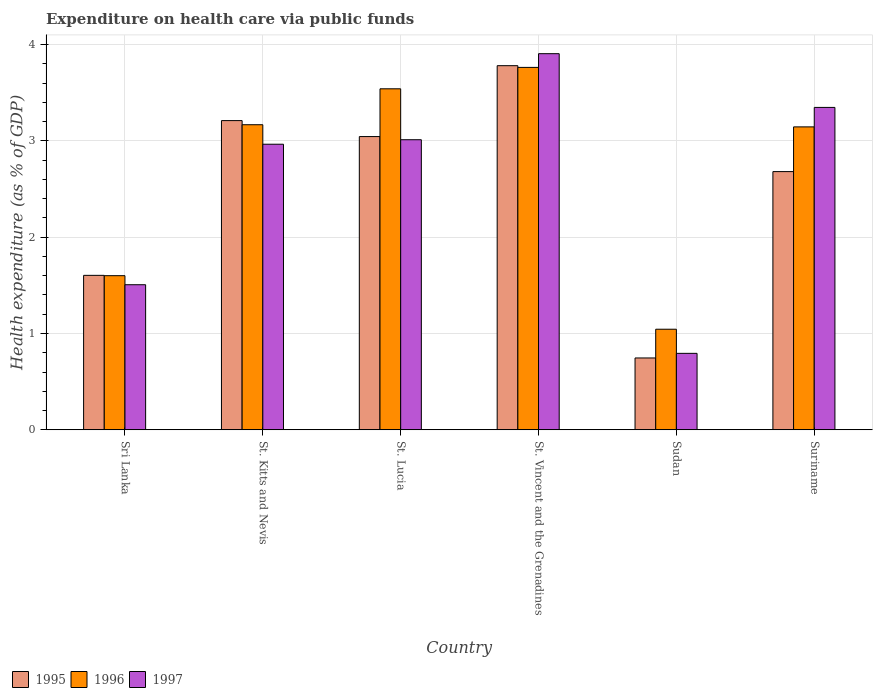How many groups of bars are there?
Your response must be concise. 6. How many bars are there on the 4th tick from the right?
Keep it short and to the point. 3. What is the label of the 2nd group of bars from the left?
Offer a terse response. St. Kitts and Nevis. What is the expenditure made on health care in 1997 in Sri Lanka?
Offer a terse response. 1.51. Across all countries, what is the maximum expenditure made on health care in 1995?
Provide a short and direct response. 3.78. Across all countries, what is the minimum expenditure made on health care in 1996?
Provide a short and direct response. 1.04. In which country was the expenditure made on health care in 1996 maximum?
Provide a succinct answer. St. Vincent and the Grenadines. In which country was the expenditure made on health care in 1997 minimum?
Your answer should be very brief. Sudan. What is the total expenditure made on health care in 1997 in the graph?
Provide a succinct answer. 15.53. What is the difference between the expenditure made on health care in 1995 in St. Vincent and the Grenadines and that in Sudan?
Offer a very short reply. 3.03. What is the difference between the expenditure made on health care in 1996 in St. Vincent and the Grenadines and the expenditure made on health care in 1997 in St. Lucia?
Keep it short and to the point. 0.75. What is the average expenditure made on health care in 1995 per country?
Provide a short and direct response. 2.51. What is the difference between the expenditure made on health care of/in 1996 and expenditure made on health care of/in 1995 in Sri Lanka?
Keep it short and to the point. -0. In how many countries, is the expenditure made on health care in 1997 greater than 1.8 %?
Ensure brevity in your answer.  4. What is the ratio of the expenditure made on health care in 1996 in St. Lucia to that in Suriname?
Provide a succinct answer. 1.13. Is the difference between the expenditure made on health care in 1996 in St. Lucia and St. Vincent and the Grenadines greater than the difference between the expenditure made on health care in 1995 in St. Lucia and St. Vincent and the Grenadines?
Give a very brief answer. Yes. What is the difference between the highest and the second highest expenditure made on health care in 1997?
Give a very brief answer. 0.34. What is the difference between the highest and the lowest expenditure made on health care in 1996?
Your answer should be very brief. 2.72. In how many countries, is the expenditure made on health care in 1995 greater than the average expenditure made on health care in 1995 taken over all countries?
Your response must be concise. 4. What does the 2nd bar from the left in Suriname represents?
Ensure brevity in your answer.  1996. What does the 1st bar from the right in Sudan represents?
Your answer should be compact. 1997. How many bars are there?
Your answer should be compact. 18. Are all the bars in the graph horizontal?
Your answer should be very brief. No. Are the values on the major ticks of Y-axis written in scientific E-notation?
Offer a very short reply. No. Where does the legend appear in the graph?
Your answer should be very brief. Bottom left. How are the legend labels stacked?
Your answer should be compact. Horizontal. What is the title of the graph?
Your answer should be compact. Expenditure on health care via public funds. What is the label or title of the Y-axis?
Your answer should be compact. Health expenditure (as % of GDP). What is the Health expenditure (as % of GDP) of 1995 in Sri Lanka?
Provide a succinct answer. 1.6. What is the Health expenditure (as % of GDP) in 1996 in Sri Lanka?
Give a very brief answer. 1.6. What is the Health expenditure (as % of GDP) in 1997 in Sri Lanka?
Your answer should be compact. 1.51. What is the Health expenditure (as % of GDP) in 1995 in St. Kitts and Nevis?
Make the answer very short. 3.21. What is the Health expenditure (as % of GDP) of 1996 in St. Kitts and Nevis?
Provide a short and direct response. 3.17. What is the Health expenditure (as % of GDP) in 1997 in St. Kitts and Nevis?
Provide a short and direct response. 2.96. What is the Health expenditure (as % of GDP) of 1995 in St. Lucia?
Ensure brevity in your answer.  3.04. What is the Health expenditure (as % of GDP) of 1996 in St. Lucia?
Make the answer very short. 3.54. What is the Health expenditure (as % of GDP) in 1997 in St. Lucia?
Your response must be concise. 3.01. What is the Health expenditure (as % of GDP) in 1995 in St. Vincent and the Grenadines?
Give a very brief answer. 3.78. What is the Health expenditure (as % of GDP) of 1996 in St. Vincent and the Grenadines?
Keep it short and to the point. 3.76. What is the Health expenditure (as % of GDP) in 1997 in St. Vincent and the Grenadines?
Offer a very short reply. 3.91. What is the Health expenditure (as % of GDP) of 1995 in Sudan?
Provide a succinct answer. 0.75. What is the Health expenditure (as % of GDP) in 1996 in Sudan?
Your answer should be very brief. 1.04. What is the Health expenditure (as % of GDP) in 1997 in Sudan?
Provide a short and direct response. 0.79. What is the Health expenditure (as % of GDP) of 1995 in Suriname?
Make the answer very short. 2.68. What is the Health expenditure (as % of GDP) of 1996 in Suriname?
Offer a terse response. 3.15. What is the Health expenditure (as % of GDP) in 1997 in Suriname?
Ensure brevity in your answer.  3.35. Across all countries, what is the maximum Health expenditure (as % of GDP) of 1995?
Your response must be concise. 3.78. Across all countries, what is the maximum Health expenditure (as % of GDP) in 1996?
Give a very brief answer. 3.76. Across all countries, what is the maximum Health expenditure (as % of GDP) in 1997?
Offer a very short reply. 3.91. Across all countries, what is the minimum Health expenditure (as % of GDP) in 1995?
Your answer should be very brief. 0.75. Across all countries, what is the minimum Health expenditure (as % of GDP) of 1996?
Provide a succinct answer. 1.04. Across all countries, what is the minimum Health expenditure (as % of GDP) of 1997?
Ensure brevity in your answer.  0.79. What is the total Health expenditure (as % of GDP) of 1995 in the graph?
Your response must be concise. 15.07. What is the total Health expenditure (as % of GDP) in 1996 in the graph?
Give a very brief answer. 16.26. What is the total Health expenditure (as % of GDP) in 1997 in the graph?
Provide a succinct answer. 15.53. What is the difference between the Health expenditure (as % of GDP) of 1995 in Sri Lanka and that in St. Kitts and Nevis?
Your answer should be compact. -1.61. What is the difference between the Health expenditure (as % of GDP) in 1996 in Sri Lanka and that in St. Kitts and Nevis?
Your answer should be very brief. -1.57. What is the difference between the Health expenditure (as % of GDP) in 1997 in Sri Lanka and that in St. Kitts and Nevis?
Keep it short and to the point. -1.46. What is the difference between the Health expenditure (as % of GDP) in 1995 in Sri Lanka and that in St. Lucia?
Provide a short and direct response. -1.44. What is the difference between the Health expenditure (as % of GDP) in 1996 in Sri Lanka and that in St. Lucia?
Make the answer very short. -1.94. What is the difference between the Health expenditure (as % of GDP) of 1997 in Sri Lanka and that in St. Lucia?
Keep it short and to the point. -1.51. What is the difference between the Health expenditure (as % of GDP) in 1995 in Sri Lanka and that in St. Vincent and the Grenadines?
Give a very brief answer. -2.18. What is the difference between the Health expenditure (as % of GDP) in 1996 in Sri Lanka and that in St. Vincent and the Grenadines?
Your answer should be compact. -2.16. What is the difference between the Health expenditure (as % of GDP) of 1997 in Sri Lanka and that in St. Vincent and the Grenadines?
Offer a terse response. -2.4. What is the difference between the Health expenditure (as % of GDP) of 1995 in Sri Lanka and that in Sudan?
Keep it short and to the point. 0.86. What is the difference between the Health expenditure (as % of GDP) in 1996 in Sri Lanka and that in Sudan?
Make the answer very short. 0.56. What is the difference between the Health expenditure (as % of GDP) in 1997 in Sri Lanka and that in Sudan?
Your answer should be very brief. 0.71. What is the difference between the Health expenditure (as % of GDP) in 1995 in Sri Lanka and that in Suriname?
Your response must be concise. -1.08. What is the difference between the Health expenditure (as % of GDP) of 1996 in Sri Lanka and that in Suriname?
Make the answer very short. -1.54. What is the difference between the Health expenditure (as % of GDP) in 1997 in Sri Lanka and that in Suriname?
Give a very brief answer. -1.84. What is the difference between the Health expenditure (as % of GDP) in 1995 in St. Kitts and Nevis and that in St. Lucia?
Ensure brevity in your answer.  0.17. What is the difference between the Health expenditure (as % of GDP) of 1996 in St. Kitts and Nevis and that in St. Lucia?
Provide a succinct answer. -0.37. What is the difference between the Health expenditure (as % of GDP) of 1997 in St. Kitts and Nevis and that in St. Lucia?
Ensure brevity in your answer.  -0.05. What is the difference between the Health expenditure (as % of GDP) in 1995 in St. Kitts and Nevis and that in St. Vincent and the Grenadines?
Ensure brevity in your answer.  -0.57. What is the difference between the Health expenditure (as % of GDP) of 1996 in St. Kitts and Nevis and that in St. Vincent and the Grenadines?
Provide a succinct answer. -0.6. What is the difference between the Health expenditure (as % of GDP) of 1997 in St. Kitts and Nevis and that in St. Vincent and the Grenadines?
Offer a terse response. -0.94. What is the difference between the Health expenditure (as % of GDP) in 1995 in St. Kitts and Nevis and that in Sudan?
Provide a succinct answer. 2.46. What is the difference between the Health expenditure (as % of GDP) in 1996 in St. Kitts and Nevis and that in Sudan?
Offer a very short reply. 2.12. What is the difference between the Health expenditure (as % of GDP) in 1997 in St. Kitts and Nevis and that in Sudan?
Provide a succinct answer. 2.17. What is the difference between the Health expenditure (as % of GDP) in 1995 in St. Kitts and Nevis and that in Suriname?
Provide a succinct answer. 0.53. What is the difference between the Health expenditure (as % of GDP) of 1996 in St. Kitts and Nevis and that in Suriname?
Your answer should be compact. 0.02. What is the difference between the Health expenditure (as % of GDP) in 1997 in St. Kitts and Nevis and that in Suriname?
Your response must be concise. -0.38. What is the difference between the Health expenditure (as % of GDP) of 1995 in St. Lucia and that in St. Vincent and the Grenadines?
Your answer should be compact. -0.74. What is the difference between the Health expenditure (as % of GDP) in 1996 in St. Lucia and that in St. Vincent and the Grenadines?
Your answer should be compact. -0.22. What is the difference between the Health expenditure (as % of GDP) in 1997 in St. Lucia and that in St. Vincent and the Grenadines?
Offer a terse response. -0.89. What is the difference between the Health expenditure (as % of GDP) in 1995 in St. Lucia and that in Sudan?
Ensure brevity in your answer.  2.3. What is the difference between the Health expenditure (as % of GDP) of 1996 in St. Lucia and that in Sudan?
Offer a very short reply. 2.5. What is the difference between the Health expenditure (as % of GDP) in 1997 in St. Lucia and that in Sudan?
Keep it short and to the point. 2.22. What is the difference between the Health expenditure (as % of GDP) in 1995 in St. Lucia and that in Suriname?
Keep it short and to the point. 0.36. What is the difference between the Health expenditure (as % of GDP) of 1996 in St. Lucia and that in Suriname?
Ensure brevity in your answer.  0.4. What is the difference between the Health expenditure (as % of GDP) in 1997 in St. Lucia and that in Suriname?
Offer a terse response. -0.34. What is the difference between the Health expenditure (as % of GDP) in 1995 in St. Vincent and the Grenadines and that in Sudan?
Your answer should be compact. 3.03. What is the difference between the Health expenditure (as % of GDP) of 1996 in St. Vincent and the Grenadines and that in Sudan?
Your answer should be very brief. 2.72. What is the difference between the Health expenditure (as % of GDP) of 1997 in St. Vincent and the Grenadines and that in Sudan?
Offer a very short reply. 3.11. What is the difference between the Health expenditure (as % of GDP) in 1995 in St. Vincent and the Grenadines and that in Suriname?
Make the answer very short. 1.1. What is the difference between the Health expenditure (as % of GDP) in 1996 in St. Vincent and the Grenadines and that in Suriname?
Keep it short and to the point. 0.62. What is the difference between the Health expenditure (as % of GDP) in 1997 in St. Vincent and the Grenadines and that in Suriname?
Give a very brief answer. 0.56. What is the difference between the Health expenditure (as % of GDP) in 1995 in Sudan and that in Suriname?
Offer a terse response. -1.93. What is the difference between the Health expenditure (as % of GDP) of 1996 in Sudan and that in Suriname?
Ensure brevity in your answer.  -2.1. What is the difference between the Health expenditure (as % of GDP) in 1997 in Sudan and that in Suriname?
Offer a very short reply. -2.55. What is the difference between the Health expenditure (as % of GDP) of 1995 in Sri Lanka and the Health expenditure (as % of GDP) of 1996 in St. Kitts and Nevis?
Keep it short and to the point. -1.56. What is the difference between the Health expenditure (as % of GDP) of 1995 in Sri Lanka and the Health expenditure (as % of GDP) of 1997 in St. Kitts and Nevis?
Make the answer very short. -1.36. What is the difference between the Health expenditure (as % of GDP) of 1996 in Sri Lanka and the Health expenditure (as % of GDP) of 1997 in St. Kitts and Nevis?
Ensure brevity in your answer.  -1.36. What is the difference between the Health expenditure (as % of GDP) in 1995 in Sri Lanka and the Health expenditure (as % of GDP) in 1996 in St. Lucia?
Give a very brief answer. -1.94. What is the difference between the Health expenditure (as % of GDP) in 1995 in Sri Lanka and the Health expenditure (as % of GDP) in 1997 in St. Lucia?
Keep it short and to the point. -1.41. What is the difference between the Health expenditure (as % of GDP) in 1996 in Sri Lanka and the Health expenditure (as % of GDP) in 1997 in St. Lucia?
Give a very brief answer. -1.41. What is the difference between the Health expenditure (as % of GDP) of 1995 in Sri Lanka and the Health expenditure (as % of GDP) of 1996 in St. Vincent and the Grenadines?
Give a very brief answer. -2.16. What is the difference between the Health expenditure (as % of GDP) of 1995 in Sri Lanka and the Health expenditure (as % of GDP) of 1997 in St. Vincent and the Grenadines?
Give a very brief answer. -2.3. What is the difference between the Health expenditure (as % of GDP) in 1996 in Sri Lanka and the Health expenditure (as % of GDP) in 1997 in St. Vincent and the Grenadines?
Provide a succinct answer. -2.3. What is the difference between the Health expenditure (as % of GDP) in 1995 in Sri Lanka and the Health expenditure (as % of GDP) in 1996 in Sudan?
Make the answer very short. 0.56. What is the difference between the Health expenditure (as % of GDP) of 1995 in Sri Lanka and the Health expenditure (as % of GDP) of 1997 in Sudan?
Offer a very short reply. 0.81. What is the difference between the Health expenditure (as % of GDP) in 1996 in Sri Lanka and the Health expenditure (as % of GDP) in 1997 in Sudan?
Your answer should be compact. 0.81. What is the difference between the Health expenditure (as % of GDP) of 1995 in Sri Lanka and the Health expenditure (as % of GDP) of 1996 in Suriname?
Provide a succinct answer. -1.54. What is the difference between the Health expenditure (as % of GDP) of 1995 in Sri Lanka and the Health expenditure (as % of GDP) of 1997 in Suriname?
Provide a succinct answer. -1.74. What is the difference between the Health expenditure (as % of GDP) in 1996 in Sri Lanka and the Health expenditure (as % of GDP) in 1997 in Suriname?
Your answer should be very brief. -1.75. What is the difference between the Health expenditure (as % of GDP) in 1995 in St. Kitts and Nevis and the Health expenditure (as % of GDP) in 1996 in St. Lucia?
Provide a short and direct response. -0.33. What is the difference between the Health expenditure (as % of GDP) in 1995 in St. Kitts and Nevis and the Health expenditure (as % of GDP) in 1997 in St. Lucia?
Offer a very short reply. 0.2. What is the difference between the Health expenditure (as % of GDP) of 1996 in St. Kitts and Nevis and the Health expenditure (as % of GDP) of 1997 in St. Lucia?
Offer a very short reply. 0.16. What is the difference between the Health expenditure (as % of GDP) of 1995 in St. Kitts and Nevis and the Health expenditure (as % of GDP) of 1996 in St. Vincent and the Grenadines?
Keep it short and to the point. -0.55. What is the difference between the Health expenditure (as % of GDP) in 1995 in St. Kitts and Nevis and the Health expenditure (as % of GDP) in 1997 in St. Vincent and the Grenadines?
Keep it short and to the point. -0.69. What is the difference between the Health expenditure (as % of GDP) of 1996 in St. Kitts and Nevis and the Health expenditure (as % of GDP) of 1997 in St. Vincent and the Grenadines?
Offer a terse response. -0.74. What is the difference between the Health expenditure (as % of GDP) of 1995 in St. Kitts and Nevis and the Health expenditure (as % of GDP) of 1996 in Sudan?
Your answer should be very brief. 2.17. What is the difference between the Health expenditure (as % of GDP) of 1995 in St. Kitts and Nevis and the Health expenditure (as % of GDP) of 1997 in Sudan?
Provide a short and direct response. 2.42. What is the difference between the Health expenditure (as % of GDP) of 1996 in St. Kitts and Nevis and the Health expenditure (as % of GDP) of 1997 in Sudan?
Your answer should be compact. 2.37. What is the difference between the Health expenditure (as % of GDP) in 1995 in St. Kitts and Nevis and the Health expenditure (as % of GDP) in 1996 in Suriname?
Offer a terse response. 0.07. What is the difference between the Health expenditure (as % of GDP) of 1995 in St. Kitts and Nevis and the Health expenditure (as % of GDP) of 1997 in Suriname?
Your answer should be compact. -0.14. What is the difference between the Health expenditure (as % of GDP) in 1996 in St. Kitts and Nevis and the Health expenditure (as % of GDP) in 1997 in Suriname?
Your response must be concise. -0.18. What is the difference between the Health expenditure (as % of GDP) in 1995 in St. Lucia and the Health expenditure (as % of GDP) in 1996 in St. Vincent and the Grenadines?
Keep it short and to the point. -0.72. What is the difference between the Health expenditure (as % of GDP) in 1995 in St. Lucia and the Health expenditure (as % of GDP) in 1997 in St. Vincent and the Grenadines?
Your answer should be very brief. -0.86. What is the difference between the Health expenditure (as % of GDP) of 1996 in St. Lucia and the Health expenditure (as % of GDP) of 1997 in St. Vincent and the Grenadines?
Your response must be concise. -0.36. What is the difference between the Health expenditure (as % of GDP) of 1995 in St. Lucia and the Health expenditure (as % of GDP) of 1996 in Sudan?
Provide a succinct answer. 2. What is the difference between the Health expenditure (as % of GDP) of 1995 in St. Lucia and the Health expenditure (as % of GDP) of 1997 in Sudan?
Your answer should be very brief. 2.25. What is the difference between the Health expenditure (as % of GDP) in 1996 in St. Lucia and the Health expenditure (as % of GDP) in 1997 in Sudan?
Provide a short and direct response. 2.75. What is the difference between the Health expenditure (as % of GDP) in 1995 in St. Lucia and the Health expenditure (as % of GDP) in 1996 in Suriname?
Provide a short and direct response. -0.1. What is the difference between the Health expenditure (as % of GDP) of 1995 in St. Lucia and the Health expenditure (as % of GDP) of 1997 in Suriname?
Offer a terse response. -0.3. What is the difference between the Health expenditure (as % of GDP) in 1996 in St. Lucia and the Health expenditure (as % of GDP) in 1997 in Suriname?
Your answer should be very brief. 0.19. What is the difference between the Health expenditure (as % of GDP) in 1995 in St. Vincent and the Grenadines and the Health expenditure (as % of GDP) in 1996 in Sudan?
Give a very brief answer. 2.74. What is the difference between the Health expenditure (as % of GDP) in 1995 in St. Vincent and the Grenadines and the Health expenditure (as % of GDP) in 1997 in Sudan?
Provide a succinct answer. 2.99. What is the difference between the Health expenditure (as % of GDP) of 1996 in St. Vincent and the Grenadines and the Health expenditure (as % of GDP) of 1997 in Sudan?
Give a very brief answer. 2.97. What is the difference between the Health expenditure (as % of GDP) of 1995 in St. Vincent and the Grenadines and the Health expenditure (as % of GDP) of 1996 in Suriname?
Offer a very short reply. 0.64. What is the difference between the Health expenditure (as % of GDP) of 1995 in St. Vincent and the Grenadines and the Health expenditure (as % of GDP) of 1997 in Suriname?
Make the answer very short. 0.43. What is the difference between the Health expenditure (as % of GDP) of 1996 in St. Vincent and the Grenadines and the Health expenditure (as % of GDP) of 1997 in Suriname?
Offer a terse response. 0.42. What is the difference between the Health expenditure (as % of GDP) of 1995 in Sudan and the Health expenditure (as % of GDP) of 1996 in Suriname?
Give a very brief answer. -2.4. What is the difference between the Health expenditure (as % of GDP) of 1995 in Sudan and the Health expenditure (as % of GDP) of 1997 in Suriname?
Provide a succinct answer. -2.6. What is the difference between the Health expenditure (as % of GDP) in 1996 in Sudan and the Health expenditure (as % of GDP) in 1997 in Suriname?
Keep it short and to the point. -2.3. What is the average Health expenditure (as % of GDP) in 1995 per country?
Offer a very short reply. 2.51. What is the average Health expenditure (as % of GDP) of 1996 per country?
Offer a terse response. 2.71. What is the average Health expenditure (as % of GDP) of 1997 per country?
Offer a very short reply. 2.59. What is the difference between the Health expenditure (as % of GDP) of 1995 and Health expenditure (as % of GDP) of 1996 in Sri Lanka?
Ensure brevity in your answer.  0. What is the difference between the Health expenditure (as % of GDP) of 1995 and Health expenditure (as % of GDP) of 1997 in Sri Lanka?
Keep it short and to the point. 0.1. What is the difference between the Health expenditure (as % of GDP) of 1996 and Health expenditure (as % of GDP) of 1997 in Sri Lanka?
Ensure brevity in your answer.  0.09. What is the difference between the Health expenditure (as % of GDP) in 1995 and Health expenditure (as % of GDP) in 1996 in St. Kitts and Nevis?
Your answer should be very brief. 0.04. What is the difference between the Health expenditure (as % of GDP) in 1995 and Health expenditure (as % of GDP) in 1997 in St. Kitts and Nevis?
Your response must be concise. 0.25. What is the difference between the Health expenditure (as % of GDP) in 1996 and Health expenditure (as % of GDP) in 1997 in St. Kitts and Nevis?
Make the answer very short. 0.2. What is the difference between the Health expenditure (as % of GDP) in 1995 and Health expenditure (as % of GDP) in 1996 in St. Lucia?
Offer a terse response. -0.5. What is the difference between the Health expenditure (as % of GDP) in 1995 and Health expenditure (as % of GDP) in 1997 in St. Lucia?
Provide a short and direct response. 0.03. What is the difference between the Health expenditure (as % of GDP) in 1996 and Health expenditure (as % of GDP) in 1997 in St. Lucia?
Offer a very short reply. 0.53. What is the difference between the Health expenditure (as % of GDP) in 1995 and Health expenditure (as % of GDP) in 1996 in St. Vincent and the Grenadines?
Make the answer very short. 0.02. What is the difference between the Health expenditure (as % of GDP) of 1995 and Health expenditure (as % of GDP) of 1997 in St. Vincent and the Grenadines?
Make the answer very short. -0.12. What is the difference between the Health expenditure (as % of GDP) in 1996 and Health expenditure (as % of GDP) in 1997 in St. Vincent and the Grenadines?
Offer a very short reply. -0.14. What is the difference between the Health expenditure (as % of GDP) of 1995 and Health expenditure (as % of GDP) of 1996 in Sudan?
Offer a terse response. -0.3. What is the difference between the Health expenditure (as % of GDP) in 1995 and Health expenditure (as % of GDP) in 1997 in Sudan?
Offer a very short reply. -0.05. What is the difference between the Health expenditure (as % of GDP) in 1996 and Health expenditure (as % of GDP) in 1997 in Sudan?
Offer a terse response. 0.25. What is the difference between the Health expenditure (as % of GDP) of 1995 and Health expenditure (as % of GDP) of 1996 in Suriname?
Offer a very short reply. -0.46. What is the difference between the Health expenditure (as % of GDP) of 1995 and Health expenditure (as % of GDP) of 1997 in Suriname?
Ensure brevity in your answer.  -0.67. What is the difference between the Health expenditure (as % of GDP) of 1996 and Health expenditure (as % of GDP) of 1997 in Suriname?
Provide a succinct answer. -0.2. What is the ratio of the Health expenditure (as % of GDP) in 1995 in Sri Lanka to that in St. Kitts and Nevis?
Your answer should be very brief. 0.5. What is the ratio of the Health expenditure (as % of GDP) of 1996 in Sri Lanka to that in St. Kitts and Nevis?
Give a very brief answer. 0.51. What is the ratio of the Health expenditure (as % of GDP) of 1997 in Sri Lanka to that in St. Kitts and Nevis?
Make the answer very short. 0.51. What is the ratio of the Health expenditure (as % of GDP) in 1995 in Sri Lanka to that in St. Lucia?
Provide a short and direct response. 0.53. What is the ratio of the Health expenditure (as % of GDP) of 1996 in Sri Lanka to that in St. Lucia?
Offer a terse response. 0.45. What is the ratio of the Health expenditure (as % of GDP) of 1997 in Sri Lanka to that in St. Lucia?
Your answer should be very brief. 0.5. What is the ratio of the Health expenditure (as % of GDP) of 1995 in Sri Lanka to that in St. Vincent and the Grenadines?
Your answer should be compact. 0.42. What is the ratio of the Health expenditure (as % of GDP) in 1996 in Sri Lanka to that in St. Vincent and the Grenadines?
Make the answer very short. 0.43. What is the ratio of the Health expenditure (as % of GDP) of 1997 in Sri Lanka to that in St. Vincent and the Grenadines?
Make the answer very short. 0.39. What is the ratio of the Health expenditure (as % of GDP) in 1995 in Sri Lanka to that in Sudan?
Make the answer very short. 2.15. What is the ratio of the Health expenditure (as % of GDP) in 1996 in Sri Lanka to that in Sudan?
Keep it short and to the point. 1.53. What is the ratio of the Health expenditure (as % of GDP) of 1997 in Sri Lanka to that in Sudan?
Offer a very short reply. 1.9. What is the ratio of the Health expenditure (as % of GDP) of 1995 in Sri Lanka to that in Suriname?
Your answer should be compact. 0.6. What is the ratio of the Health expenditure (as % of GDP) of 1996 in Sri Lanka to that in Suriname?
Ensure brevity in your answer.  0.51. What is the ratio of the Health expenditure (as % of GDP) of 1997 in Sri Lanka to that in Suriname?
Your response must be concise. 0.45. What is the ratio of the Health expenditure (as % of GDP) in 1995 in St. Kitts and Nevis to that in St. Lucia?
Make the answer very short. 1.05. What is the ratio of the Health expenditure (as % of GDP) in 1996 in St. Kitts and Nevis to that in St. Lucia?
Provide a succinct answer. 0.89. What is the ratio of the Health expenditure (as % of GDP) in 1997 in St. Kitts and Nevis to that in St. Lucia?
Offer a very short reply. 0.98. What is the ratio of the Health expenditure (as % of GDP) of 1995 in St. Kitts and Nevis to that in St. Vincent and the Grenadines?
Provide a short and direct response. 0.85. What is the ratio of the Health expenditure (as % of GDP) in 1996 in St. Kitts and Nevis to that in St. Vincent and the Grenadines?
Your answer should be compact. 0.84. What is the ratio of the Health expenditure (as % of GDP) in 1997 in St. Kitts and Nevis to that in St. Vincent and the Grenadines?
Your response must be concise. 0.76. What is the ratio of the Health expenditure (as % of GDP) of 1995 in St. Kitts and Nevis to that in Sudan?
Your answer should be very brief. 4.3. What is the ratio of the Health expenditure (as % of GDP) in 1996 in St. Kitts and Nevis to that in Sudan?
Offer a very short reply. 3.03. What is the ratio of the Health expenditure (as % of GDP) of 1997 in St. Kitts and Nevis to that in Sudan?
Offer a terse response. 3.74. What is the ratio of the Health expenditure (as % of GDP) of 1995 in St. Kitts and Nevis to that in Suriname?
Provide a succinct answer. 1.2. What is the ratio of the Health expenditure (as % of GDP) of 1996 in St. Kitts and Nevis to that in Suriname?
Your response must be concise. 1.01. What is the ratio of the Health expenditure (as % of GDP) of 1997 in St. Kitts and Nevis to that in Suriname?
Keep it short and to the point. 0.89. What is the ratio of the Health expenditure (as % of GDP) of 1995 in St. Lucia to that in St. Vincent and the Grenadines?
Provide a short and direct response. 0.81. What is the ratio of the Health expenditure (as % of GDP) in 1996 in St. Lucia to that in St. Vincent and the Grenadines?
Keep it short and to the point. 0.94. What is the ratio of the Health expenditure (as % of GDP) in 1997 in St. Lucia to that in St. Vincent and the Grenadines?
Provide a short and direct response. 0.77. What is the ratio of the Health expenditure (as % of GDP) in 1995 in St. Lucia to that in Sudan?
Your answer should be compact. 4.08. What is the ratio of the Health expenditure (as % of GDP) in 1996 in St. Lucia to that in Sudan?
Make the answer very short. 3.39. What is the ratio of the Health expenditure (as % of GDP) in 1997 in St. Lucia to that in Sudan?
Your answer should be compact. 3.79. What is the ratio of the Health expenditure (as % of GDP) of 1995 in St. Lucia to that in Suriname?
Give a very brief answer. 1.14. What is the ratio of the Health expenditure (as % of GDP) in 1996 in St. Lucia to that in Suriname?
Provide a succinct answer. 1.13. What is the ratio of the Health expenditure (as % of GDP) of 1997 in St. Lucia to that in Suriname?
Provide a succinct answer. 0.9. What is the ratio of the Health expenditure (as % of GDP) of 1995 in St. Vincent and the Grenadines to that in Sudan?
Make the answer very short. 5.07. What is the ratio of the Health expenditure (as % of GDP) of 1996 in St. Vincent and the Grenadines to that in Sudan?
Make the answer very short. 3.6. What is the ratio of the Health expenditure (as % of GDP) of 1997 in St. Vincent and the Grenadines to that in Sudan?
Give a very brief answer. 4.92. What is the ratio of the Health expenditure (as % of GDP) in 1995 in St. Vincent and the Grenadines to that in Suriname?
Provide a succinct answer. 1.41. What is the ratio of the Health expenditure (as % of GDP) in 1996 in St. Vincent and the Grenadines to that in Suriname?
Provide a short and direct response. 1.2. What is the ratio of the Health expenditure (as % of GDP) in 1995 in Sudan to that in Suriname?
Offer a terse response. 0.28. What is the ratio of the Health expenditure (as % of GDP) of 1996 in Sudan to that in Suriname?
Keep it short and to the point. 0.33. What is the ratio of the Health expenditure (as % of GDP) in 1997 in Sudan to that in Suriname?
Give a very brief answer. 0.24. What is the difference between the highest and the second highest Health expenditure (as % of GDP) of 1995?
Provide a short and direct response. 0.57. What is the difference between the highest and the second highest Health expenditure (as % of GDP) of 1996?
Provide a succinct answer. 0.22. What is the difference between the highest and the second highest Health expenditure (as % of GDP) in 1997?
Make the answer very short. 0.56. What is the difference between the highest and the lowest Health expenditure (as % of GDP) of 1995?
Make the answer very short. 3.03. What is the difference between the highest and the lowest Health expenditure (as % of GDP) in 1996?
Your response must be concise. 2.72. What is the difference between the highest and the lowest Health expenditure (as % of GDP) in 1997?
Provide a short and direct response. 3.11. 